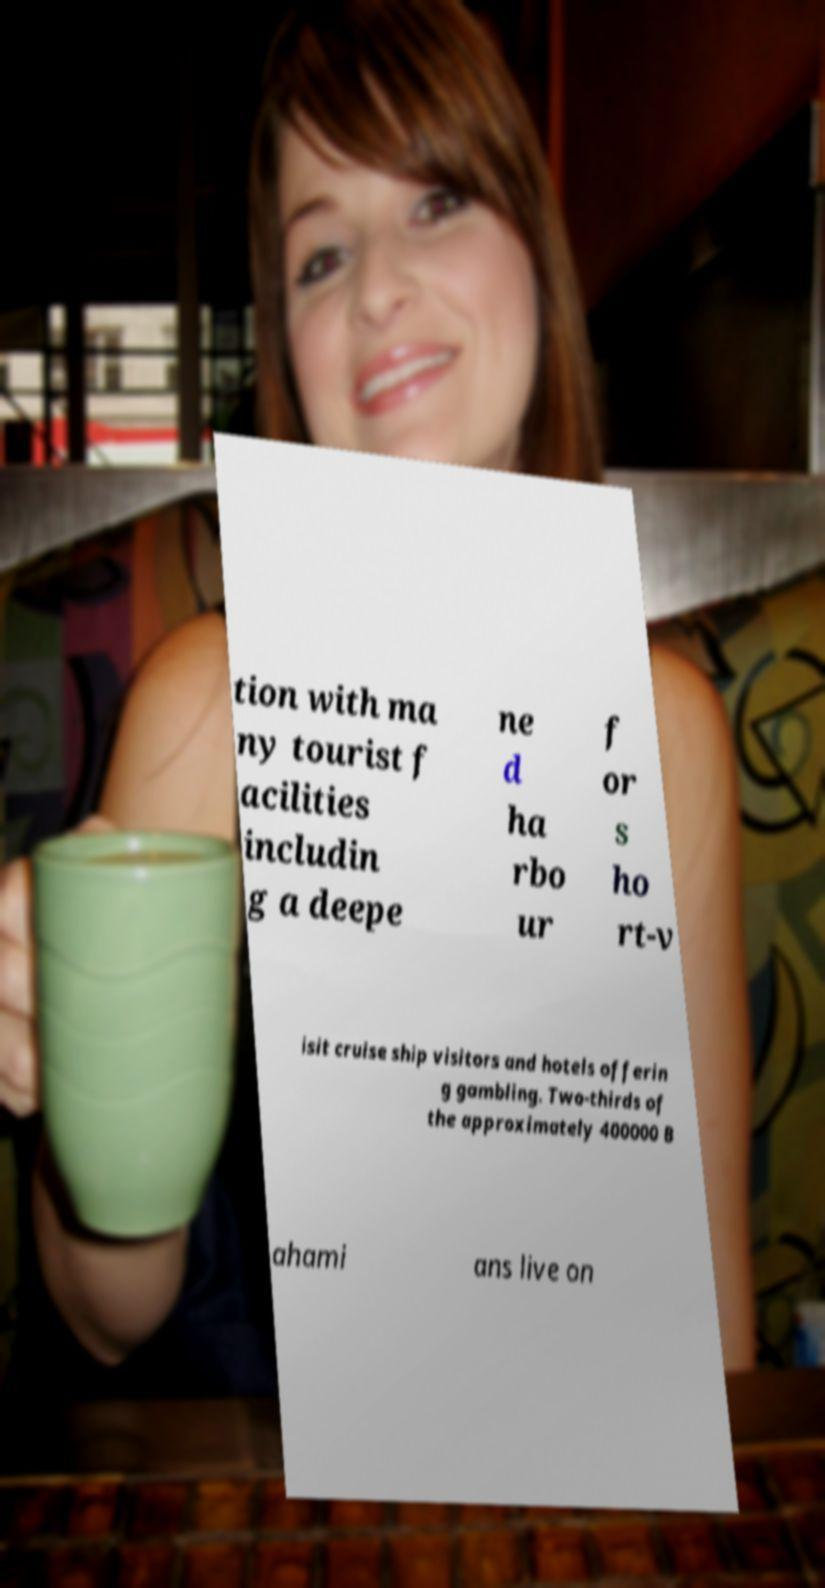Could you extract and type out the text from this image? tion with ma ny tourist f acilities includin g a deepe ne d ha rbo ur f or s ho rt-v isit cruise ship visitors and hotels offerin g gambling. Two-thirds of the approximately 400000 B ahami ans live on 